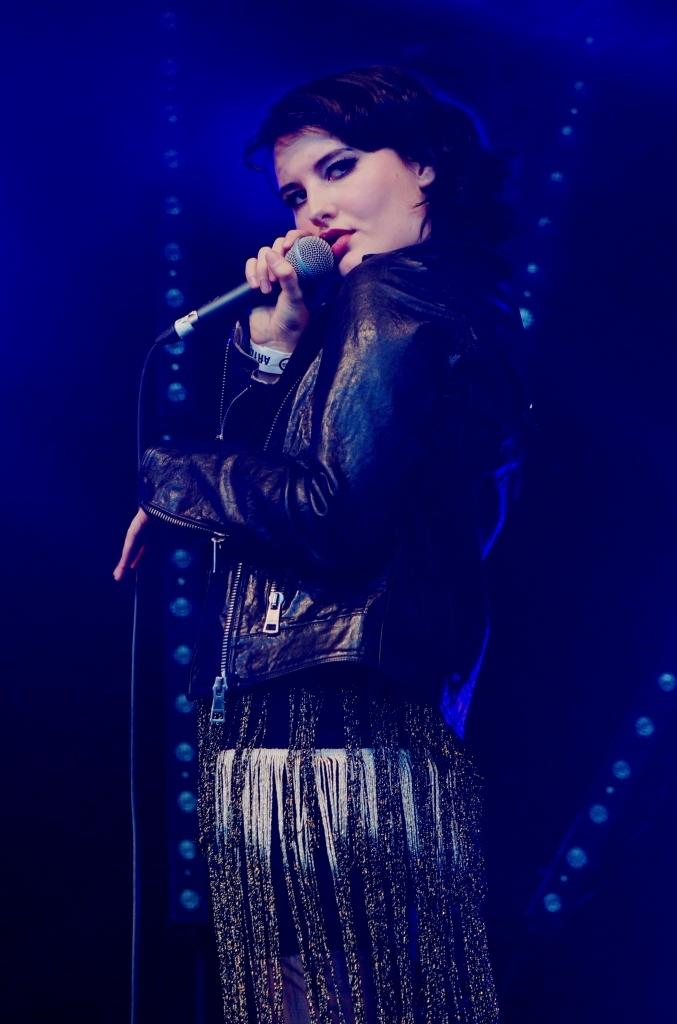What is the main subject of the image? There is a person in the image. What is the person doing in the image? The person is standing and holding a mic. What type of corn is being harvested in the image? There is no corn present in the image; it features a person standing and holding a mic. What is the profit margin of the recess activity in the image? There is no recess activity or profit margin mentioned in the image; it only shows a person standing and holding a mic. 